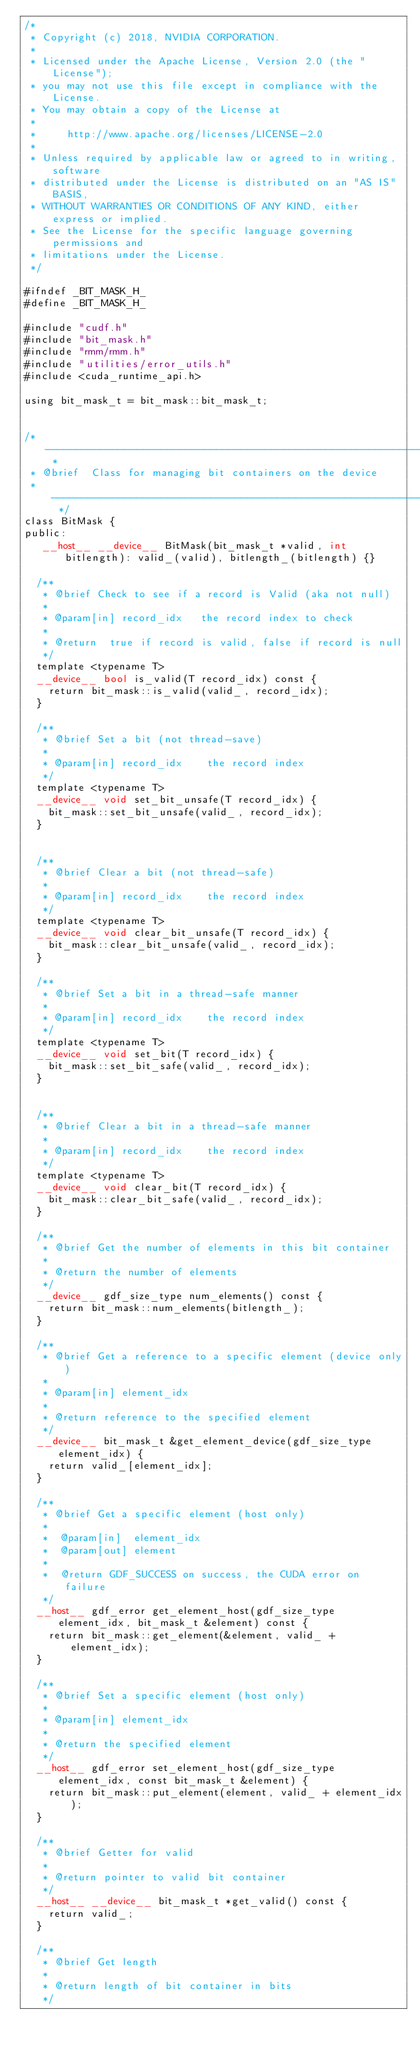Convert code to text. <code><loc_0><loc_0><loc_500><loc_500><_Cuda_>/*
 * Copyright (c) 2018, NVIDIA CORPORATION.
 *
 * Licensed under the Apache License, Version 2.0 (the "License");
 * you may not use this file except in compliance with the License.
 * You may obtain a copy of the License at
 *
 *     http://www.apache.org/licenses/LICENSE-2.0
 *
 * Unless required by applicable law or agreed to in writing, software
 * distributed under the License is distributed on an "AS IS" BASIS,
 * WITHOUT WARRANTIES OR CONDITIONS OF ANY KIND, either express or implied.
 * See the License for the specific language governing permissions and
 * limitations under the License.
 */

#ifndef _BIT_MASK_H_
#define _BIT_MASK_H_

#include "cudf.h"
#include "bit_mask.h"
#include "rmm/rmm.h"
#include "utilities/error_utils.h"
#include <cuda_runtime_api.h>

using bit_mask_t = bit_mask::bit_mask_t;


/* ---------------------------------------------------------------------------- *
 * @brief  Class for managing bit containers on the device
 * ---------------------------------------------------------------------------- */
class BitMask {
public:
   __host__ __device__ BitMask(bit_mask_t *valid, int bitlength): valid_(valid), bitlength_(bitlength) {}

  /**
   * @brief Check to see if a record is Valid (aka not null)
   *
   * @param[in] record_idx   the record index to check
   *
   * @return  true if record is valid, false if record is null
   */
  template <typename T>
  __device__ bool is_valid(T record_idx) const {
    return bit_mask::is_valid(valid_, record_idx);
  }

  /**
   * @brief Set a bit (not thread-save)
   *
   * @param[in] record_idx    the record index
   */
  template <typename T>
  __device__ void set_bit_unsafe(T record_idx) {
    bit_mask::set_bit_unsafe(valid_, record_idx);
  }


  /**
   * @brief Clear a bit (not thread-safe)
   *
   * @param[in] record_idx    the record index
   */
  template <typename T>
  __device__ void clear_bit_unsafe(T record_idx) {
    bit_mask::clear_bit_unsafe(valid_, record_idx);
  }

  /**
   * @brief Set a bit in a thread-safe manner
   *
   * @param[in] record_idx    the record index
   */
  template <typename T>
  __device__ void set_bit(T record_idx) {
    bit_mask::set_bit_safe(valid_, record_idx);
  }


  /**
   * @brief Clear a bit in a thread-safe manner
   *
   * @param[in] record_idx    the record index
   */
  template <typename T>
  __device__ void clear_bit(T record_idx) {
    bit_mask::clear_bit_safe(valid_, record_idx);
  }

  /**
   * @brief Get the number of elements in this bit container
   *
   * @return the number of elements
   */
  __device__ gdf_size_type num_elements() const {
    return bit_mask::num_elements(bitlength_);
  }

  /**
   * @brief Get a reference to a specific element (device only)
   *
   * @param[in] element_idx
   *
   * @return reference to the specified element
   */
  __device__ bit_mask_t &get_element_device(gdf_size_type element_idx) {
    return valid_[element_idx];
  }

  /**
   * @brief Get a specific element (host only)
   *
   *  @param[in]  element_idx
   *  @param[out] element
   *
   *  @return GDF_SUCCESS on success, the CUDA error on failure
   */
  __host__ gdf_error get_element_host(gdf_size_type element_idx, bit_mask_t &element) const {
    return bit_mask::get_element(&element, valid_ + element_idx);
  }

  /**
   * @brief Set a specific element (host only)
   *
   * @param[in] element_idx
   *
   * @return the specified element
   */
  __host__ gdf_error set_element_host(gdf_size_type element_idx, const bit_mask_t &element) {
    return bit_mask::put_element(element, valid_ + element_idx);
  }

  /**
   * @brief Getter for valid
   *
   * @return pointer to valid bit container
   */
  __host__ __device__ bit_mask_t *get_valid() const {
    return valid_;
  }

  /**
   * @brief Get length
   *
   * @return length of bit container in bits
   */</code> 